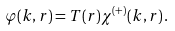<formula> <loc_0><loc_0><loc_500><loc_500>\varphi ( { k } , { r } ) = T ( r ) \chi ^ { ( + ) } ( { k } , { r } ) \, .</formula> 